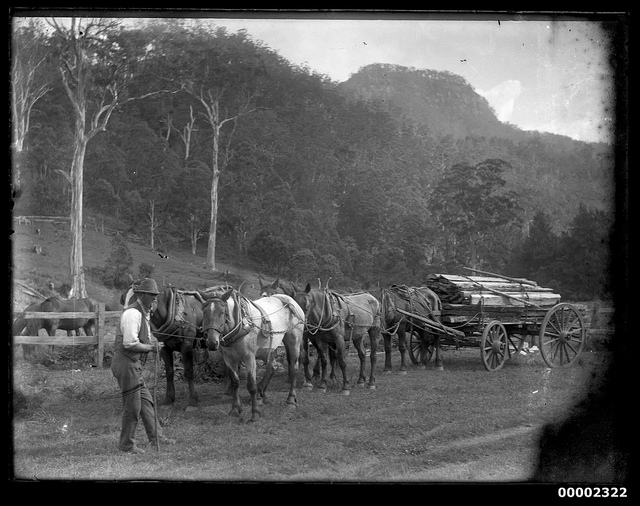What can you infer about the time period of this photograph? The photograph gives off an early 20th-century vibe. The style of the wagon, the attire of the person standing beside the horses, and the black-and-white nature of the image suggest it was taken during a time when horse-drawn wagons were still commonly used for transport, prior to the widespread adoption of motorized vehicles. 